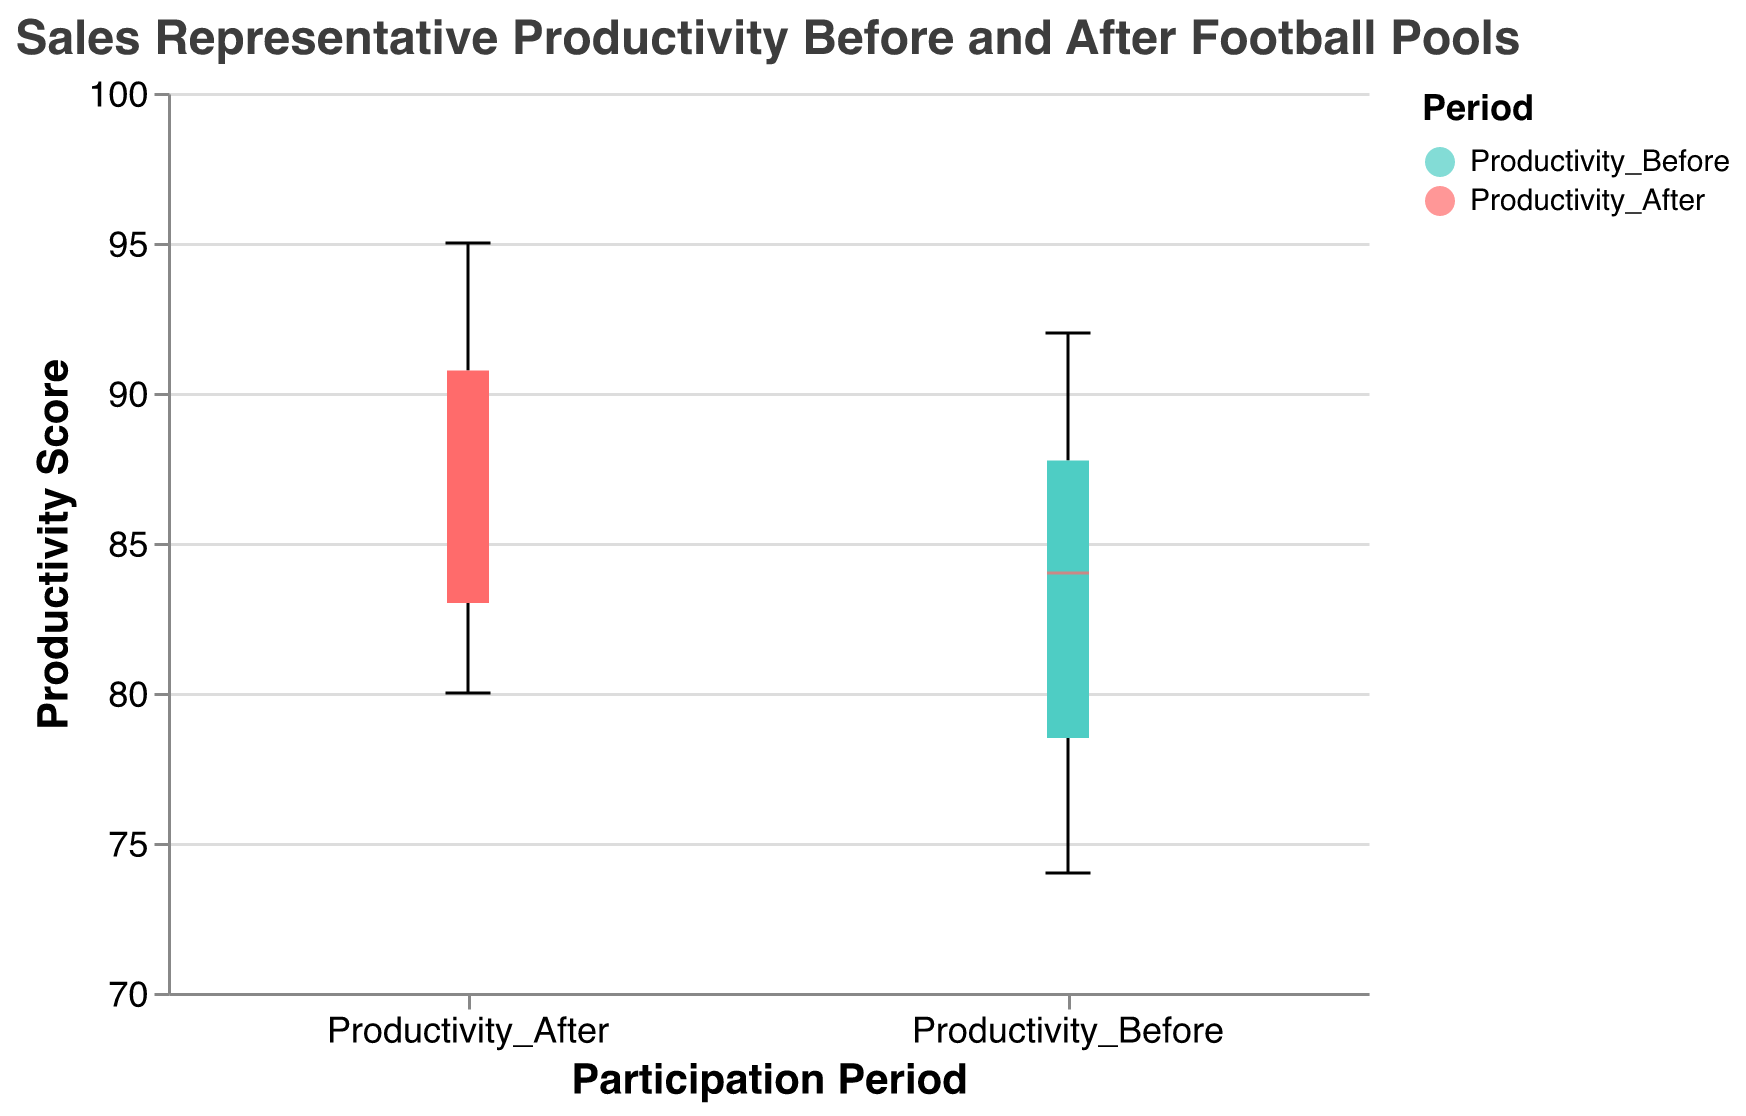What's the title of the figure? The title is located at the top of the figure, which states the main purpose or subject of the plot.
Answer: Sales Representative Productivity Before and After Football Pools What do the colors in the figure represent? The colors distinguish different periods of productivity; one color represents 'Productivity_Before' and the other represents 'Productivity_After'.
Answer: Periods of productivity What is the axis title for x? The x-axis title describes the categories along the x-axis, indicating what is being measured there.
Answer: Participation Period What is the axis title for y? The y-axis title details what is being measured vertically in the plot, in this case, it refers to productivity scores.
Answer: Productivity Score What is the median productivity score before participating in the football pools? Look at the median line within the 'Productivity_Before' boxplot to obtain the median value.
Answer: Approximately 84 What is the median productivity score after participating in the football pools? Look at the median line within the 'Productivity_After' boxplot to find the median value.
Answer: Approximately 88 How many data points were used to create each box plot? Count the data entries listed in the data values used for both 'Productivity_Before' and 'Productivity_After'. There are 10 unique sales representatives in total.
Answer: 10 What's the main insight we can derive from the notched parts of the box plots? The notches on a box plot represent the confidence interval around the median, allowing us to compare whether medians are significantly different. If the notches do not overlap, the medians are significantly different.
Answer: The medians are likely different Is the productivity score variation larger before or after participating in the football pools? Compare the interquartile ranges (IQR) of the 'Productivity_Before' box plot and the 'Productivity_After' box plot. The IQR is the distance between the top and bottom edges of the box.
Answer: Before participating What is the approximate range of productivity scores after participating in the football pools? Identify the lowest and highest points in the 'Productivity_After' box plot, which represent the range.
Answer: About 80 to 95 